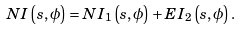<formula> <loc_0><loc_0><loc_500><loc_500>N I \left ( s , \phi \right ) = N I _ { 1 } \left ( s , \phi \right ) + E I _ { 2 } \left ( s , \phi \right ) .</formula> 